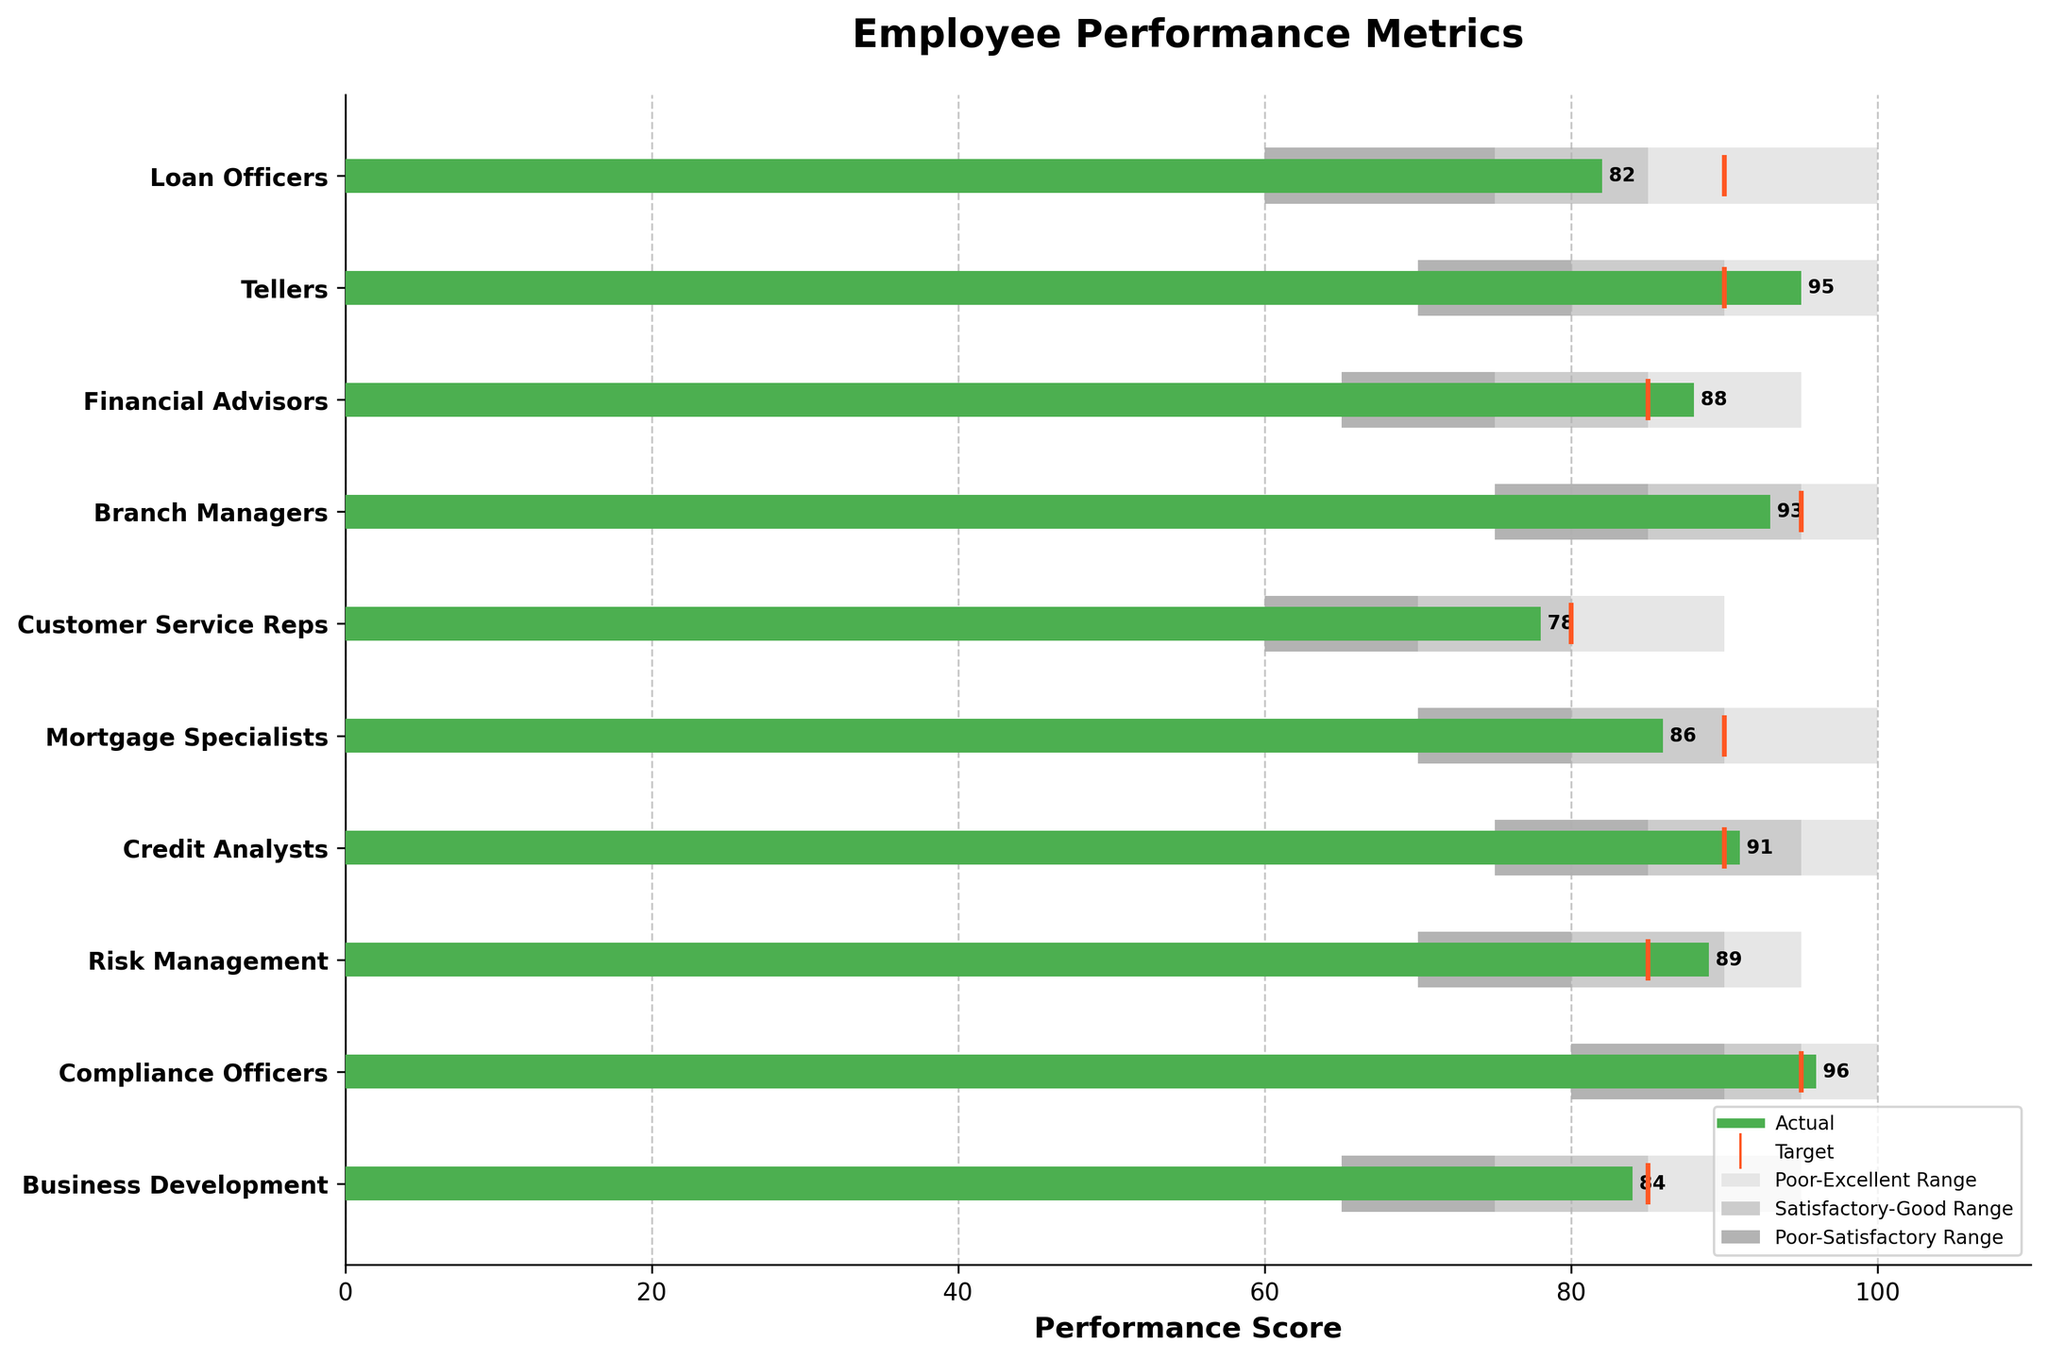What's the title of the chart? The title of the chart is written at the top. It provides a brief description of what the chart is about.
Answer: Employee Performance Metrics How many categories are there in the chart? Count the number of different roles listed on the y-axis.
Answer: 10 What is the actual performance score of the Mortgage Specialists? Look at the bar associated with Mortgage Specialists and read the value at the end of the green bar.
Answer: 86 Which category has the highest actual performance score? Look at all the green bars and identify the one that extends the furthest to the right.
Answer: Compliance Officers Is the actual performance of Tellers above or below their target? Compare the actual value represented by the end of the green bar for Tellers to the red target marker.
Answer: Above What's the difference between the actual and target performance scores for Loan Officers? Subtract the actual score (82) from the target score (90) for Loan Officers.
Answer: 8 Which category meets their target exactly? Identify the category where the green bar endpoint aligns with the red target marker.
Answer: Financial Advisors How many categories have an actual performance score greater than 90? Count the number of green bars that extend past the value of 90 on the x-axis.
Answer: 5 What is the average target performance score across all categories? Sum all the target values and divide by the number of categories. (90 + 90 + 85 + 95 + 80 + 90 + 90 + 85 + 95 + 85) / 10
Answer: 88.5 